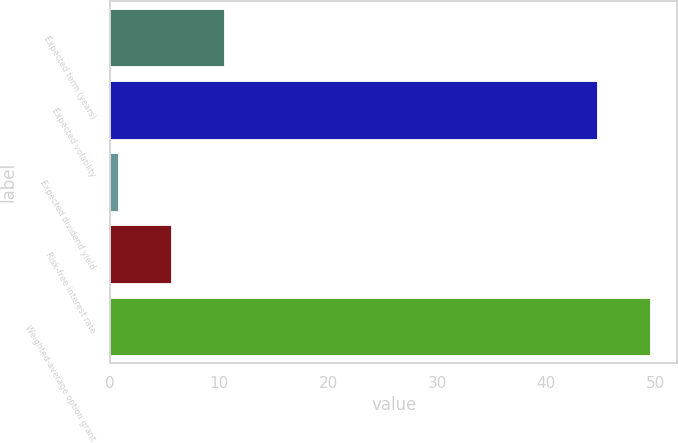Convert chart to OTSL. <chart><loc_0><loc_0><loc_500><loc_500><bar_chart><fcel>Expected term (years)<fcel>Expected volatility<fcel>Expected dividend yield<fcel>Risk-free interest rate<fcel>Weighted-average option grant<nl><fcel>10.4<fcel>44.7<fcel>0.72<fcel>5.56<fcel>49.54<nl></chart> 